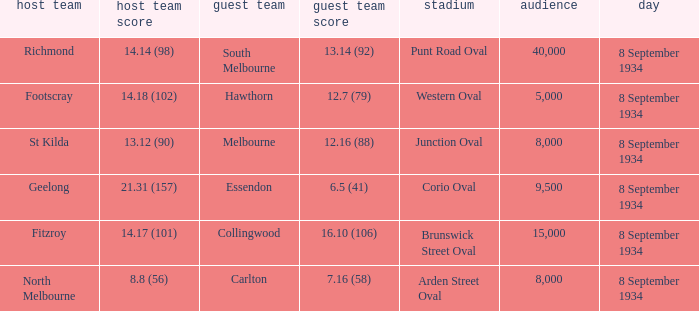When the Home team scored 14.14 (98), what did the Away Team score? 13.14 (92). 